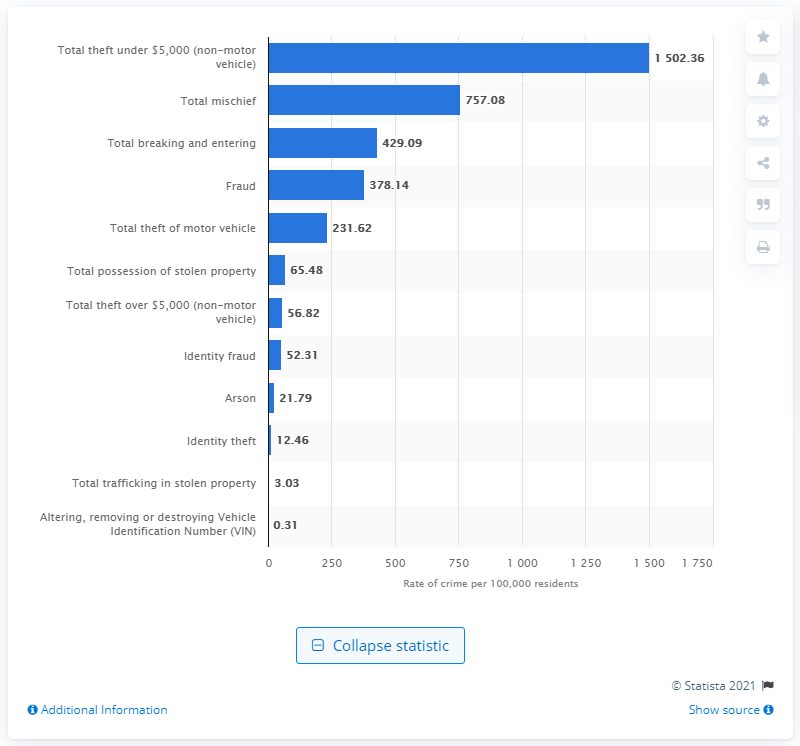List a handful of essential elements in this visual. In 2019, there were 757.08 reported incidents of mischief per 100,000 residents in Canada. 